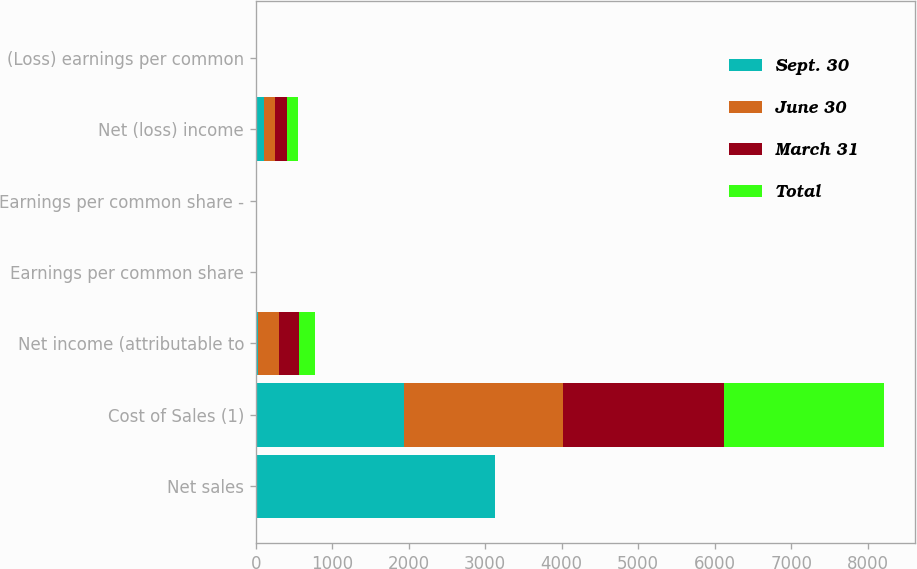Convert chart. <chart><loc_0><loc_0><loc_500><loc_500><stacked_bar_chart><ecel><fcel>Net sales<fcel>Cost of Sales (1)<fcel>Net income (attributable to<fcel>Earnings per common share<fcel>Earnings per common share -<fcel>Net (loss) income<fcel>(Loss) earnings per common<nl><fcel>Sept. 30<fcel>3126<fcel>1944<fcel>30<fcel>0.18<fcel>0.18<fcel>111<fcel>0.68<nl><fcel>June 30<fcel>1.63<fcel>2076<fcel>272<fcel>1.64<fcel>1.63<fcel>146<fcel>0.89<nl><fcel>March 31<fcel>1.63<fcel>2108<fcel>262<fcel>1.59<fcel>1.58<fcel>159<fcel>0.96<nl><fcel>Total<fcel>1.63<fcel>2086<fcel>205<fcel>1.26<fcel>1.24<fcel>142<fcel>0.85<nl></chart> 